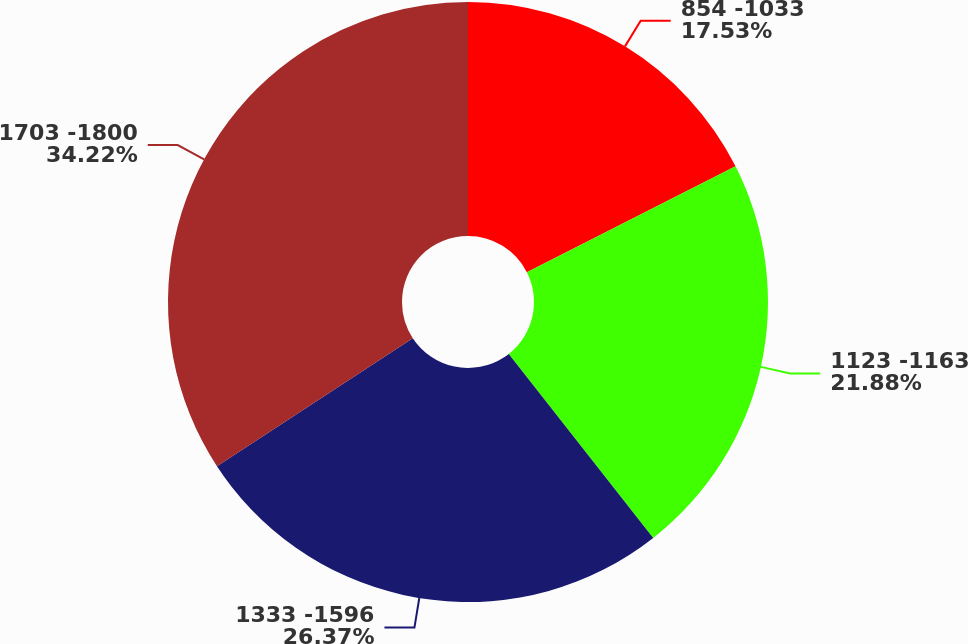<chart> <loc_0><loc_0><loc_500><loc_500><pie_chart><fcel>854 -1033<fcel>1123 -1163<fcel>1333 -1596<fcel>1703 -1800<nl><fcel>17.53%<fcel>21.88%<fcel>26.37%<fcel>34.22%<nl></chart> 